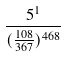<formula> <loc_0><loc_0><loc_500><loc_500>\frac { 5 ^ { 1 } } { ( \frac { 1 0 8 } { 3 6 7 } ) ^ { 4 6 8 } }</formula> 